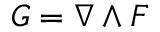<formula> <loc_0><loc_0><loc_500><loc_500>G = \nabla \wedge F</formula> 